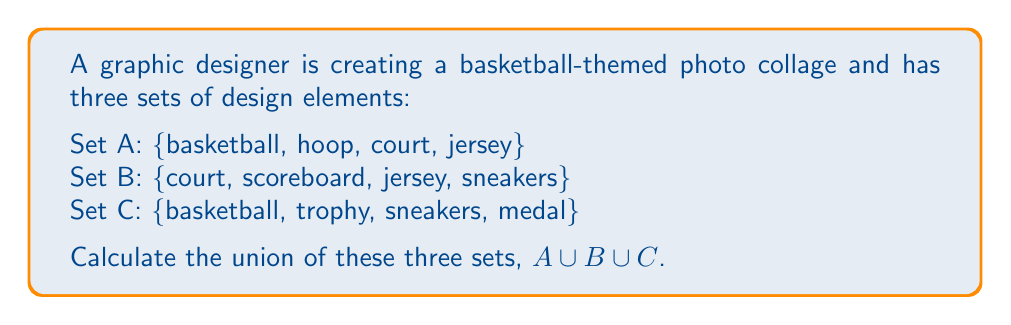Solve this math problem. To find the union of these three sets, we need to combine all unique elements from each set. Let's approach this step-by-step:

1. First, let's list out all elements from set A:
   {basketball, hoop, court, jersey}

2. Now, let's add any new elements from set B that aren't already included:
   - court and jersey are already present
   - We add scoreboard and sneakers
   {basketball, hoop, court, jersey, scoreboard, sneakers}

3. Finally, let's add any new elements from set C that aren't already included:
   - basketball and sneakers are already present
   - We add trophy and medal
   {basketball, hoop, court, jersey, scoreboard, sneakers, trophy, medal}

The resulting set contains all unique elements from sets A, B, and C. This is the definition of the union of these sets.

Mathematically, we can express this as:

$$A \cup B \cup C = \{x | x \in A \text{ or } x \in B \text{ or } x \in C\}$$

Where $x$ represents any element in the resulting set.
Answer: $A \cup B \cup C = \{basketball, hoop, court, jersey, scoreboard, sneakers, trophy, medal\}$ 